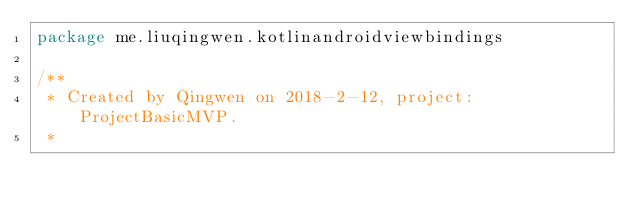<code> <loc_0><loc_0><loc_500><loc_500><_Kotlin_>package me.liuqingwen.kotlinandroidviewbindings

/**
 * Created by Qingwen on 2018-2-12, project: ProjectBasicMVP.
 *</code> 